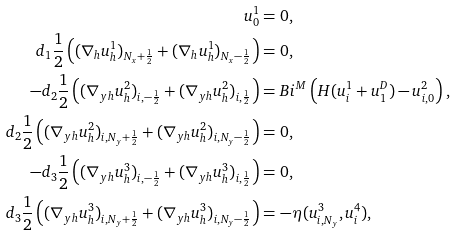<formula> <loc_0><loc_0><loc_500><loc_500>u ^ { 1 } _ { 0 } & = 0 , \\ d _ { 1 } \frac { 1 } { 2 } \left ( ( \nabla _ { h } u ^ { 1 } _ { h } ) _ { N _ { x } + \frac { 1 } { 2 } } + ( \nabla _ { h } u ^ { 1 } _ { h } ) _ { N _ { x } - \frac { 1 } { 2 } } \right ) & = 0 , \\ - d _ { 2 } \frac { 1 } { 2 } \left ( ( \nabla _ { y h } u ^ { 2 } _ { h } ) _ { i , - \frac { 1 } { 2 } } + ( \nabla _ { y h } u ^ { 2 } _ { h } ) _ { i , \frac { 1 } { 2 } } \right ) & = B i ^ { M } \left ( H ( u ^ { 1 } _ { i } + u _ { 1 } ^ { D } ) - u ^ { 2 } _ { i , 0 } \right ) , \\ d _ { 2 } \frac { 1 } { 2 } \left ( ( \nabla _ { y h } u ^ { 2 } _ { h } ) _ { i , N _ { y } + \frac { 1 } { 2 } } + ( \nabla _ { y h } u ^ { 2 } _ { h } ) _ { i , N _ { y } - \frac { 1 } { 2 } } \right ) & = 0 , \\ - d _ { 3 } \frac { 1 } { 2 } \left ( ( \nabla _ { y h } u ^ { 3 } _ { h } ) _ { i , - \frac { 1 } { 2 } } + ( \nabla _ { y h } u ^ { 3 } _ { h } ) _ { i , \frac { 1 } { 2 } } \right ) & = 0 , \\ d _ { 3 } \frac { 1 } { 2 } \left ( ( \nabla _ { y h } u ^ { 3 } _ { h } ) _ { i , N _ { y } + \frac { 1 } { 2 } } + ( \nabla _ { y h } u ^ { 3 } _ { h } ) _ { i , N _ { y } - \frac { 1 } { 2 } } \right ) & = - \eta ( u ^ { 3 } _ { i , N _ { y } } , u ^ { 4 } _ { i } ) ,</formula> 